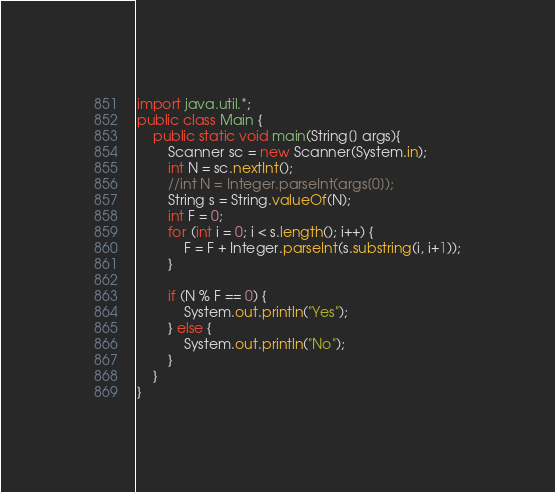Convert code to text. <code><loc_0><loc_0><loc_500><loc_500><_Java_>
import java.util.*;
public class Main {
	public static void main(String[] args){
		Scanner sc = new Scanner(System.in);
		int N = sc.nextInt();
		//int N = Integer.parseInt(args[0]);
		String s = String.valueOf(N);
		int F = 0;
		for (int i = 0; i < s.length(); i++) {
			F = F + Integer.parseInt(s.substring(i, i+1));
		}
		
		if (N % F == 0) {
			System.out.println("Yes");
		} else {
			System.out.println("No");
		}
	}
}
</code> 